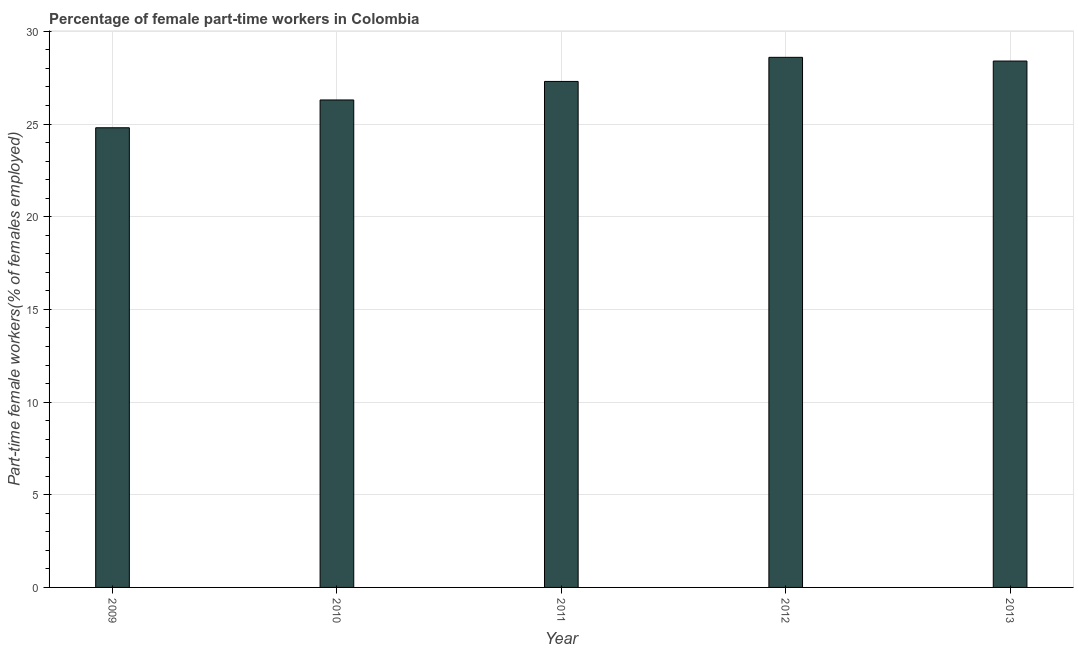What is the title of the graph?
Make the answer very short. Percentage of female part-time workers in Colombia. What is the label or title of the Y-axis?
Your answer should be very brief. Part-time female workers(% of females employed). What is the percentage of part-time female workers in 2011?
Your answer should be compact. 27.3. Across all years, what is the maximum percentage of part-time female workers?
Keep it short and to the point. 28.6. Across all years, what is the minimum percentage of part-time female workers?
Your response must be concise. 24.8. In which year was the percentage of part-time female workers maximum?
Offer a terse response. 2012. In which year was the percentage of part-time female workers minimum?
Offer a very short reply. 2009. What is the sum of the percentage of part-time female workers?
Make the answer very short. 135.4. What is the average percentage of part-time female workers per year?
Offer a terse response. 27.08. What is the median percentage of part-time female workers?
Make the answer very short. 27.3. In how many years, is the percentage of part-time female workers greater than 5 %?
Provide a succinct answer. 5. Do a majority of the years between 2010 and 2013 (inclusive) have percentage of part-time female workers greater than 26 %?
Provide a succinct answer. Yes. Is the sum of the percentage of part-time female workers in 2009 and 2011 greater than the maximum percentage of part-time female workers across all years?
Your response must be concise. Yes. In how many years, is the percentage of part-time female workers greater than the average percentage of part-time female workers taken over all years?
Offer a very short reply. 3. How many bars are there?
Your response must be concise. 5. How many years are there in the graph?
Offer a very short reply. 5. What is the difference between two consecutive major ticks on the Y-axis?
Keep it short and to the point. 5. What is the Part-time female workers(% of females employed) in 2009?
Your response must be concise. 24.8. What is the Part-time female workers(% of females employed) of 2010?
Provide a succinct answer. 26.3. What is the Part-time female workers(% of females employed) of 2011?
Provide a short and direct response. 27.3. What is the Part-time female workers(% of females employed) in 2012?
Keep it short and to the point. 28.6. What is the Part-time female workers(% of females employed) of 2013?
Your answer should be very brief. 28.4. What is the difference between the Part-time female workers(% of females employed) in 2009 and 2010?
Make the answer very short. -1.5. What is the difference between the Part-time female workers(% of females employed) in 2009 and 2012?
Give a very brief answer. -3.8. What is the difference between the Part-time female workers(% of females employed) in 2010 and 2011?
Your answer should be very brief. -1. What is the difference between the Part-time female workers(% of females employed) in 2010 and 2012?
Give a very brief answer. -2.3. What is the difference between the Part-time female workers(% of females employed) in 2010 and 2013?
Your response must be concise. -2.1. What is the difference between the Part-time female workers(% of females employed) in 2012 and 2013?
Keep it short and to the point. 0.2. What is the ratio of the Part-time female workers(% of females employed) in 2009 to that in 2010?
Your answer should be very brief. 0.94. What is the ratio of the Part-time female workers(% of females employed) in 2009 to that in 2011?
Your answer should be very brief. 0.91. What is the ratio of the Part-time female workers(% of females employed) in 2009 to that in 2012?
Offer a terse response. 0.87. What is the ratio of the Part-time female workers(% of females employed) in 2009 to that in 2013?
Provide a succinct answer. 0.87. What is the ratio of the Part-time female workers(% of females employed) in 2010 to that in 2011?
Your answer should be very brief. 0.96. What is the ratio of the Part-time female workers(% of females employed) in 2010 to that in 2012?
Provide a short and direct response. 0.92. What is the ratio of the Part-time female workers(% of females employed) in 2010 to that in 2013?
Ensure brevity in your answer.  0.93. What is the ratio of the Part-time female workers(% of females employed) in 2011 to that in 2012?
Offer a terse response. 0.95. 